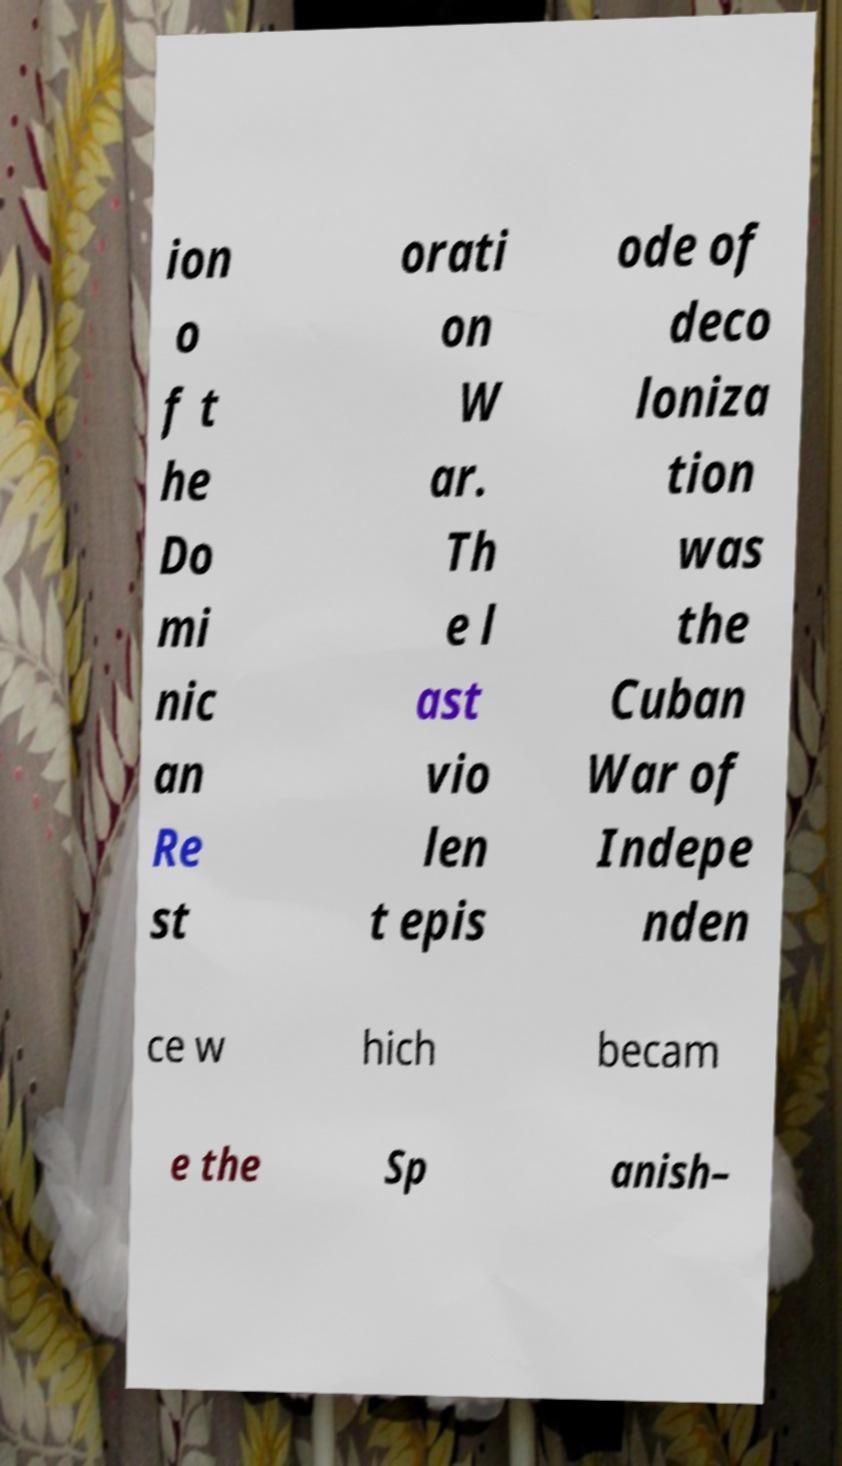Could you assist in decoding the text presented in this image and type it out clearly? ion o f t he Do mi nic an Re st orati on W ar. Th e l ast vio len t epis ode of deco loniza tion was the Cuban War of Indepe nden ce w hich becam e the Sp anish– 